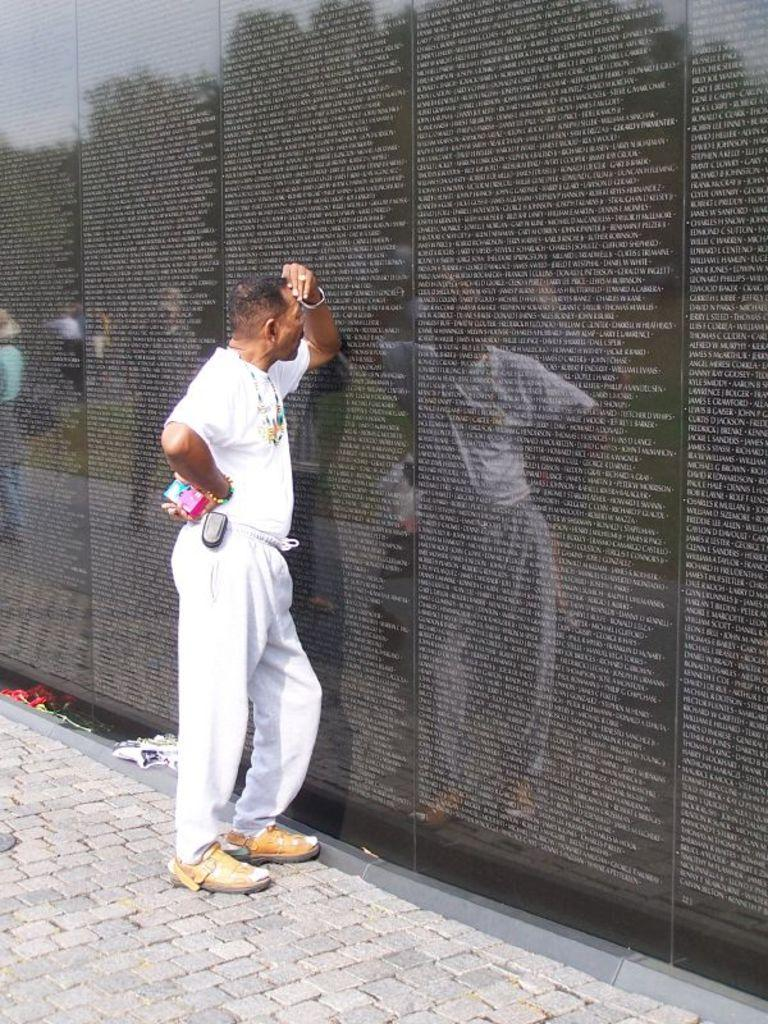What is the main subject of the image? There is a person standing in the image. Where is the person standing? The person is standing on a pathway. What is in front of the person? There is a wall in front of the person. What can be seen on the wall? The wall has letters carved on it. Can you hear the voice of the fairies in the image? There are no fairies or voices present in the image; it only features a person standing on a pathway with a wall in front of them. 